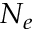<formula> <loc_0><loc_0><loc_500><loc_500>N _ { e }</formula> 